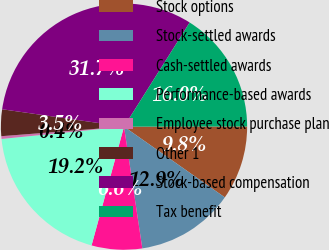Convert chart. <chart><loc_0><loc_0><loc_500><loc_500><pie_chart><fcel>Stock options<fcel>Stock-settled awards<fcel>Cash-settled awards<fcel>Performance-based awards<fcel>Employee stock purchase plan<fcel>Other 1<fcel>Stock-based compensation<fcel>Tax benefit<nl><fcel>9.76%<fcel>12.89%<fcel>6.62%<fcel>19.16%<fcel>0.36%<fcel>3.49%<fcel>31.7%<fcel>16.03%<nl></chart> 